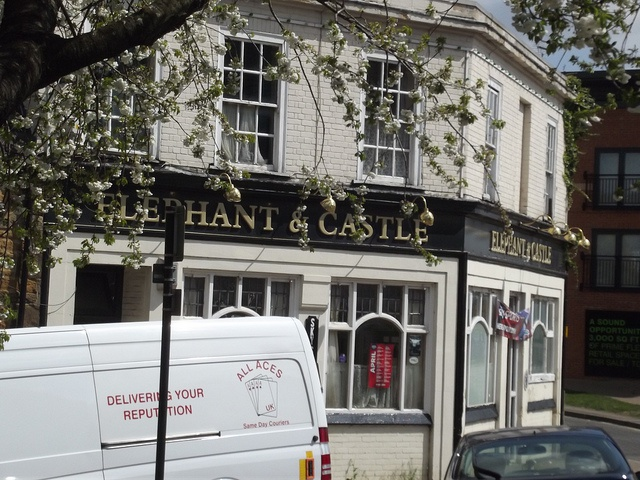Describe the objects in this image and their specific colors. I can see truck in black, lightgray, darkgray, and gray tones and car in black, gray, and darkblue tones in this image. 